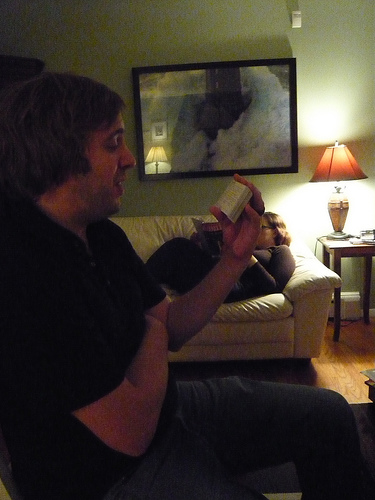<image>
Is the lamp next to the man? No. The lamp is not positioned next to the man. They are located in different areas of the scene. Is the woman in front of the couch? No. The woman is not in front of the couch. The spatial positioning shows a different relationship between these objects. 